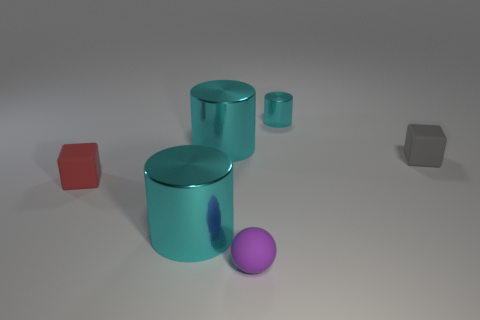How many cyan cylinders must be subtracted to get 1 cyan cylinders? 2 Add 2 big green matte balls. How many objects exist? 8 Subtract all tiny cylinders. How many cylinders are left? 2 Subtract all cubes. How many objects are left? 4 Subtract 2 cylinders. How many cylinders are left? 1 Subtract all gray blocks. How many blocks are left? 1 Subtract 0 green balls. How many objects are left? 6 Subtract all brown cubes. Subtract all red cylinders. How many cubes are left? 2 Subtract all blue cylinders. How many blue cubes are left? 0 Subtract all cyan objects. Subtract all rubber objects. How many objects are left? 0 